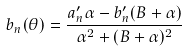Convert formula to latex. <formula><loc_0><loc_0><loc_500><loc_500>b _ { n } ( \theta ) = \frac { a _ { n } ^ { \prime } \alpha - b _ { n } ^ { \prime } ( B + \alpha ) } { \alpha ^ { 2 } + ( B + \alpha ) ^ { 2 } }</formula> 